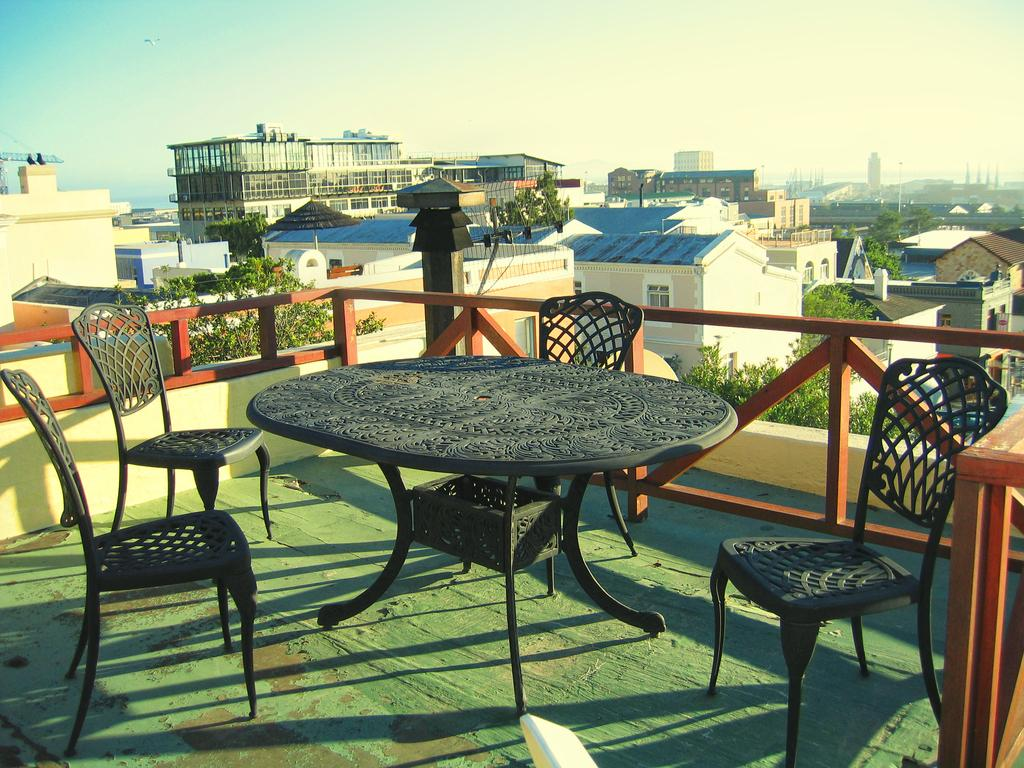What type of furniture is present in the image? There are chairs and a table in the image. Where are the chairs and table located? The chairs and table are on the floor. What else can be seen in the image besides the furniture? There is a fence visible in the image. What is visible in the background of the image? There are trees, buildings, and the sky visible in the background of the image. Can you describe the stream that runs through the image? There is no stream present in the image. 